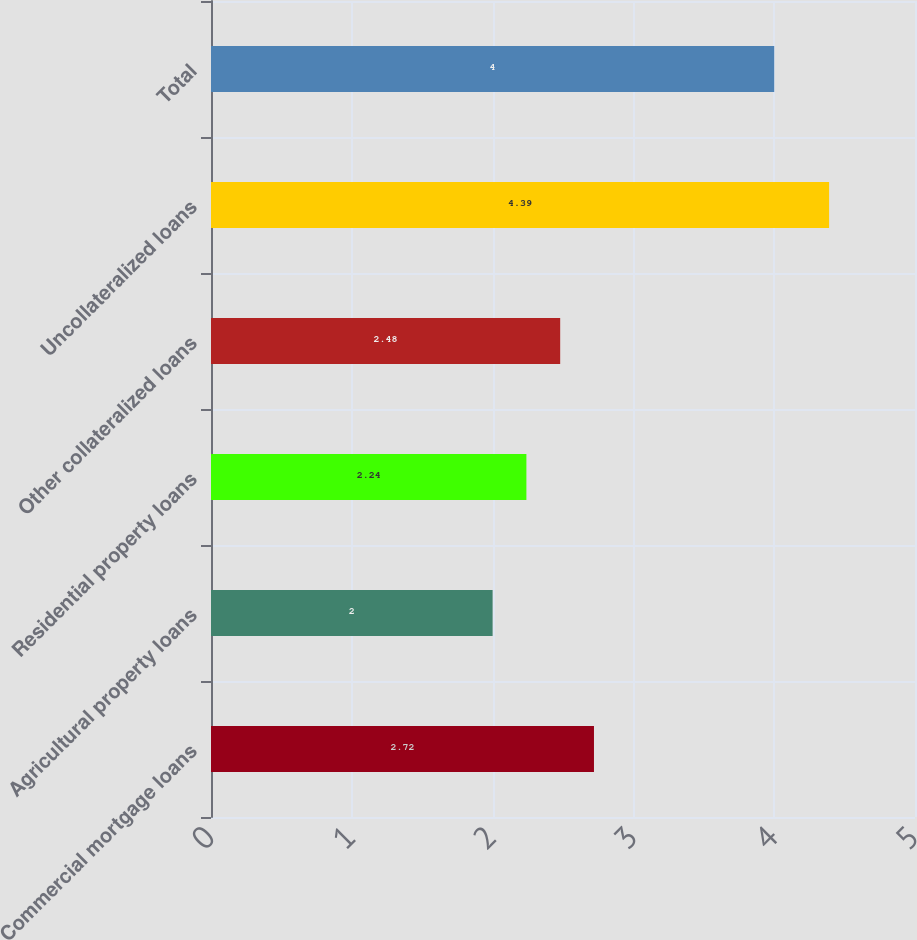<chart> <loc_0><loc_0><loc_500><loc_500><bar_chart><fcel>Commercial mortgage loans<fcel>Agricultural property loans<fcel>Residential property loans<fcel>Other collateralized loans<fcel>Uncollateralized loans<fcel>Total<nl><fcel>2.72<fcel>2<fcel>2.24<fcel>2.48<fcel>4.39<fcel>4<nl></chart> 